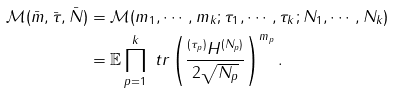<formula> <loc_0><loc_0><loc_500><loc_500>\mathcal { M } ( \bar { m } , \bar { \tau } , \bar { N } ) & = \mathcal { M } ( m _ { 1 } , \cdots , m _ { k } ; \tau _ { 1 } , \cdots , \tau _ { k } ; N _ { 1 } , \cdots , N _ { k } ) \\ & = \mathbb { E } \prod _ { p = 1 } ^ { k } \ t r \left ( \frac { ^ { ( \tau _ { p } ) } { H } ^ { ( N _ { p } ) } } { 2 \sqrt { N _ { p } } } \right ) ^ { m _ { p } } .</formula> 